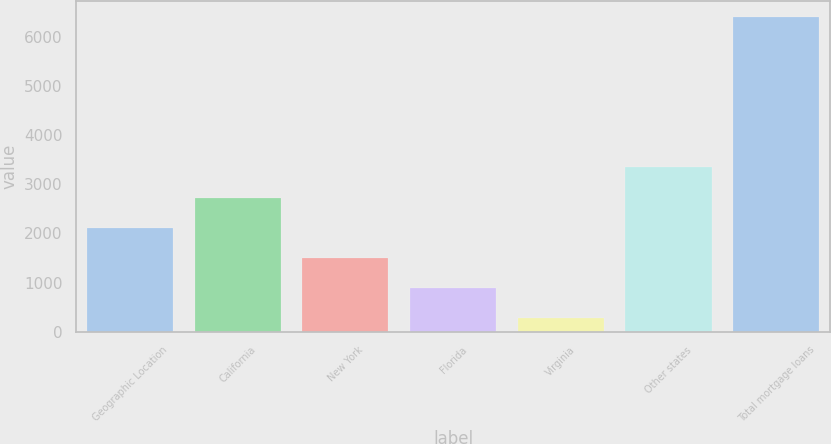<chart> <loc_0><loc_0><loc_500><loc_500><bar_chart><fcel>Geographic Location<fcel>California<fcel>New York<fcel>Florida<fcel>Virginia<fcel>Other states<fcel>Total mortgage loans<nl><fcel>2117.69<fcel>2730.92<fcel>1504.46<fcel>891.23<fcel>278<fcel>3344.15<fcel>6410.3<nl></chart> 